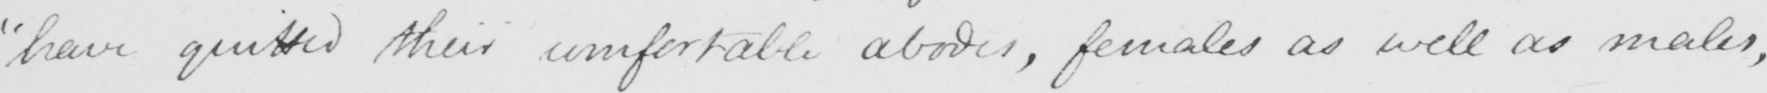Can you read and transcribe this handwriting? "have quitted their comfortable abodes, females as well as males, 